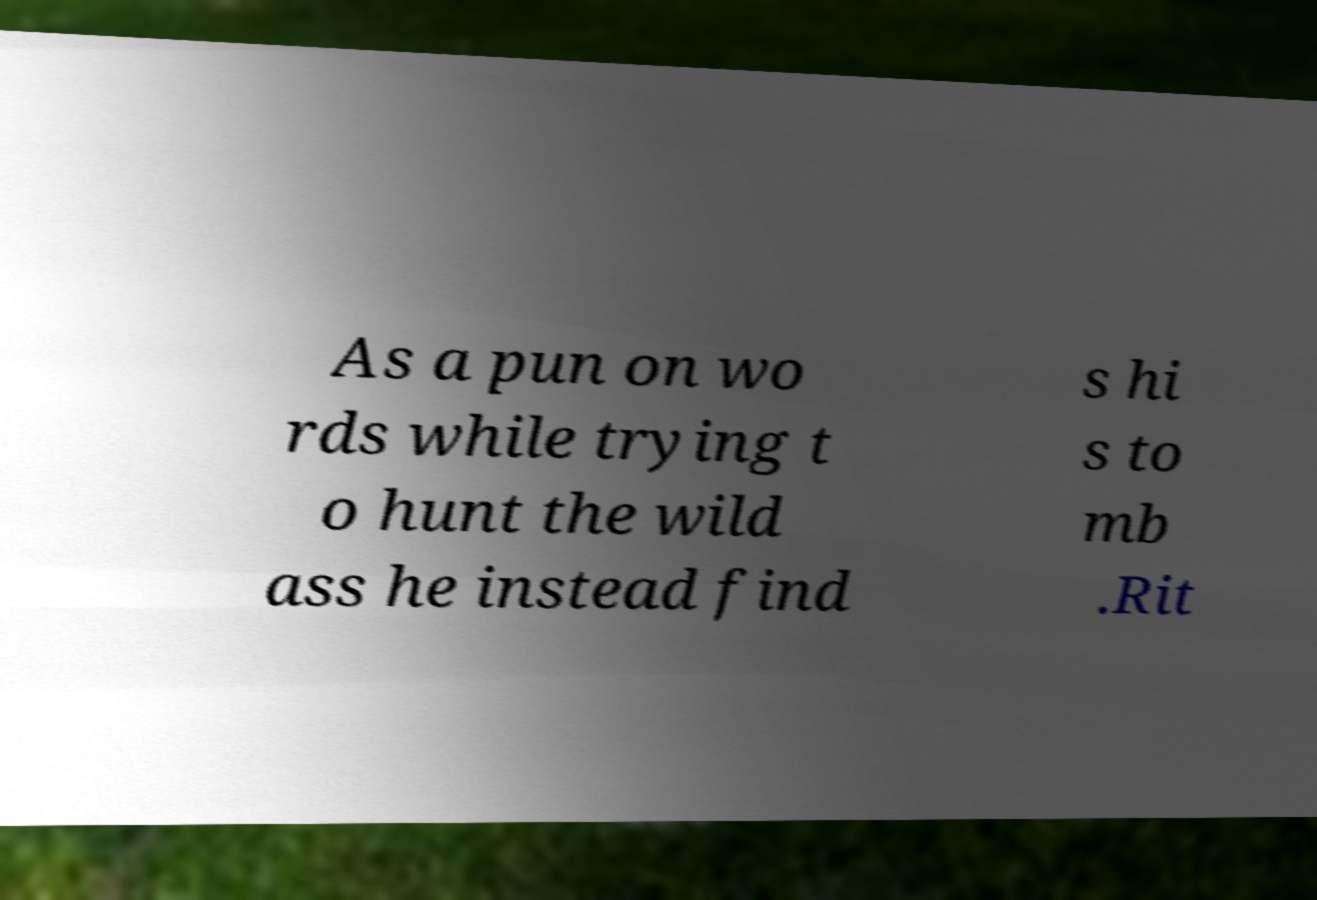I need the written content from this picture converted into text. Can you do that? As a pun on wo rds while trying t o hunt the wild ass he instead find s hi s to mb .Rit 